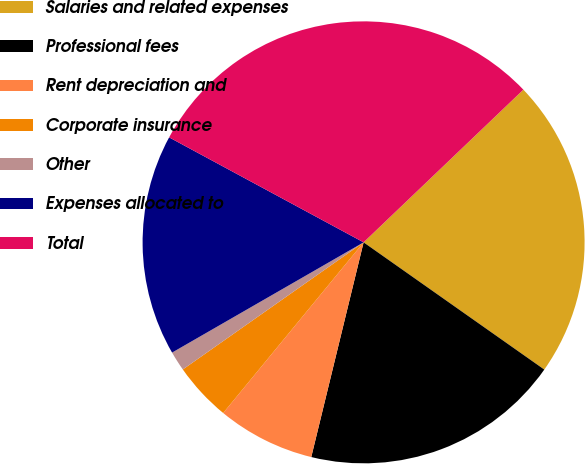Convert chart to OTSL. <chart><loc_0><loc_0><loc_500><loc_500><pie_chart><fcel>Salaries and related expenses<fcel>Professional fees<fcel>Rent depreciation and<fcel>Corporate insurance<fcel>Other<fcel>Expenses allocated to<fcel>Total<nl><fcel>21.9%<fcel>19.04%<fcel>7.15%<fcel>4.29%<fcel>1.44%<fcel>16.19%<fcel>29.98%<nl></chart> 